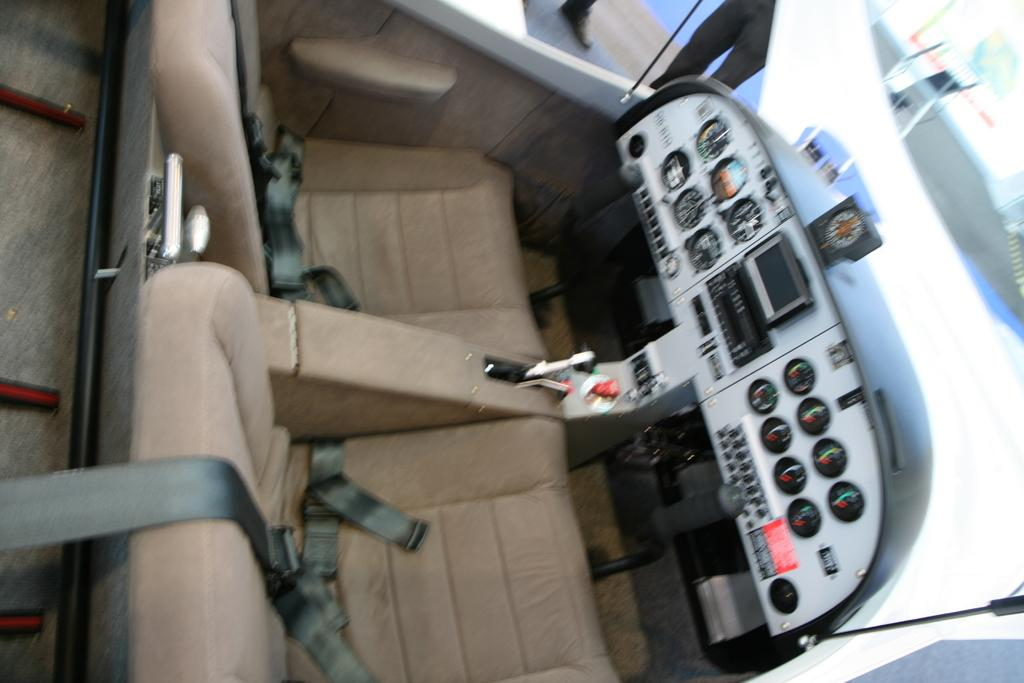What is the setting of the image? The image is taken inside a vehicle. What can be found inside the vehicle? There are seats, belts, a screen, and meters inside the vehicle. What material is used for the windows in the vehicle? There is glass in the vehicle, which is used for the windows. What can be seen through the glass in the image? Legs and an object are visible through the glass in the image. What time is it according to the stomach of the person in the image? There is no indication of the time or the person's stomach in the image, so it cannot be determined. 